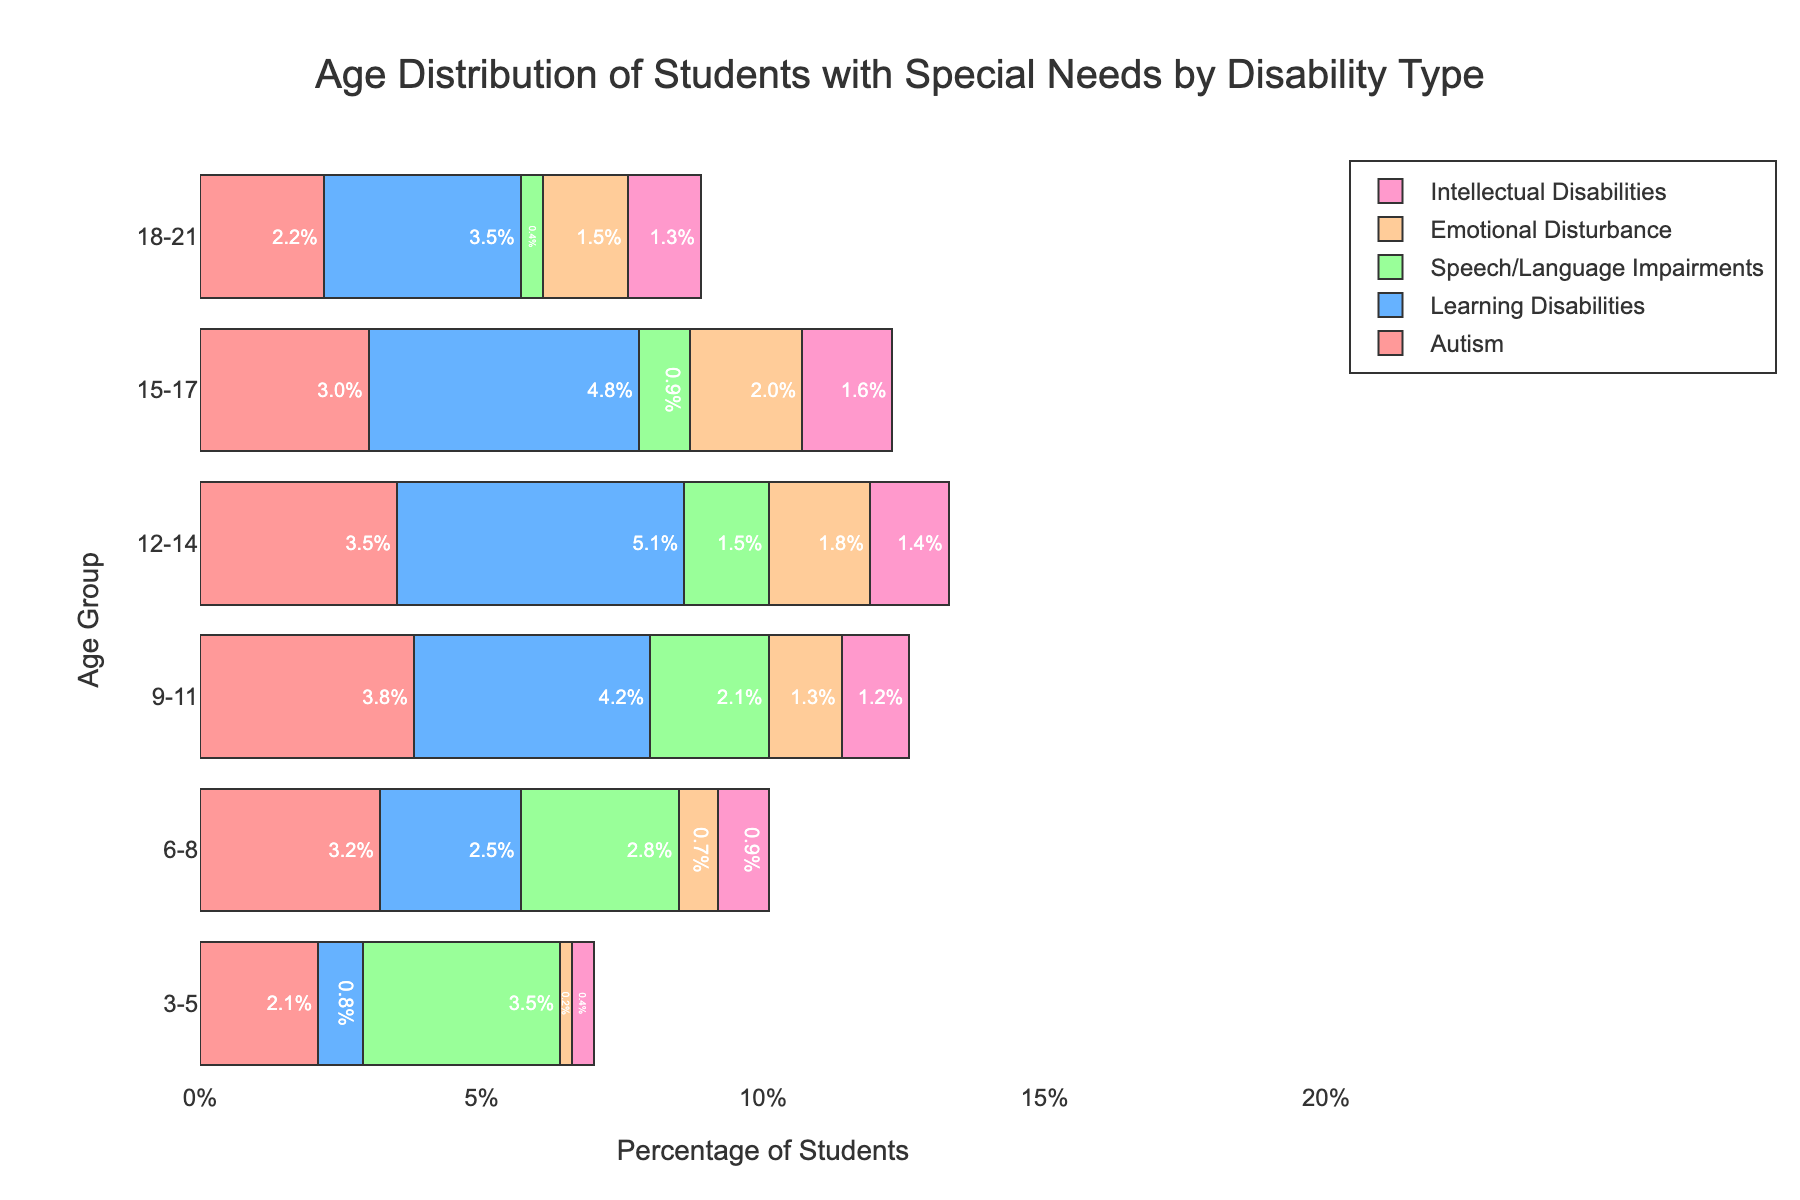What is the title of the figure? The title can be found at the top, in the center of the figure.
Answer: Age Distribution of Students with Special Needs by Disability Type How many age groups are represented on the y-axis? Count the distinct age ranges listed on the y-axis.
Answer: 6 Which age group has the highest percentage of students with learning disabilities? Look at the bar lengths for learning disabilities across all age groups and identify the highest percentage.
Answer: 12-14 Compare the percentage of students with autism in the age groups 3-5 and 9-11. Which is higher? Compare the lengths of the bars for autism for the age groups 3-5 and 9-11.
Answer: 9-11 What is the percentage of students with speech/language impairments in the age group 6-8? Look at the length of the bar for speech/language impairments in the age group 6-8.
Answer: 2.8% Summarize the percentage distribution of students with emotional disturbance across all age groups. List the percentages for emotional disturbance across each age group.
Answer: 3-5: 0.2%, 6-8: 0.7%, 9-11: 1.3%, 12-14: 1.8%, 15-17: 2.0%, 18-21: 1.5% In which age group is the percentage of students with intellectual disabilities the smallest? Compare the lengths of the bars for intellectual disabilities across all age groups and identify the smallest one.
Answer: 3-5 How does the percentage of students with autism in the age group 15-17 compare to those with emotional disturbance in the same group? Compare the lengths of the bars for autism and emotional disturbance in the age group 15-17.
Answer: Emotional Disturbance is higher Calculate the average percentage of students with intellectual disabilities across all age groups. Sum the percentages of intellectual disabilities for all age groups and divide by the number of age groups. (0.4 + 0.9 + 1.2 + 1.4 + 1.6 + 1.3) / 6 = 1.13
Answer: 1.13% Which disability type has the most students in the age group 18-21? Look at the bar lengths for all disability types in the age group 18-21 and identify the longest one.
Answer: Learning Disabilities 